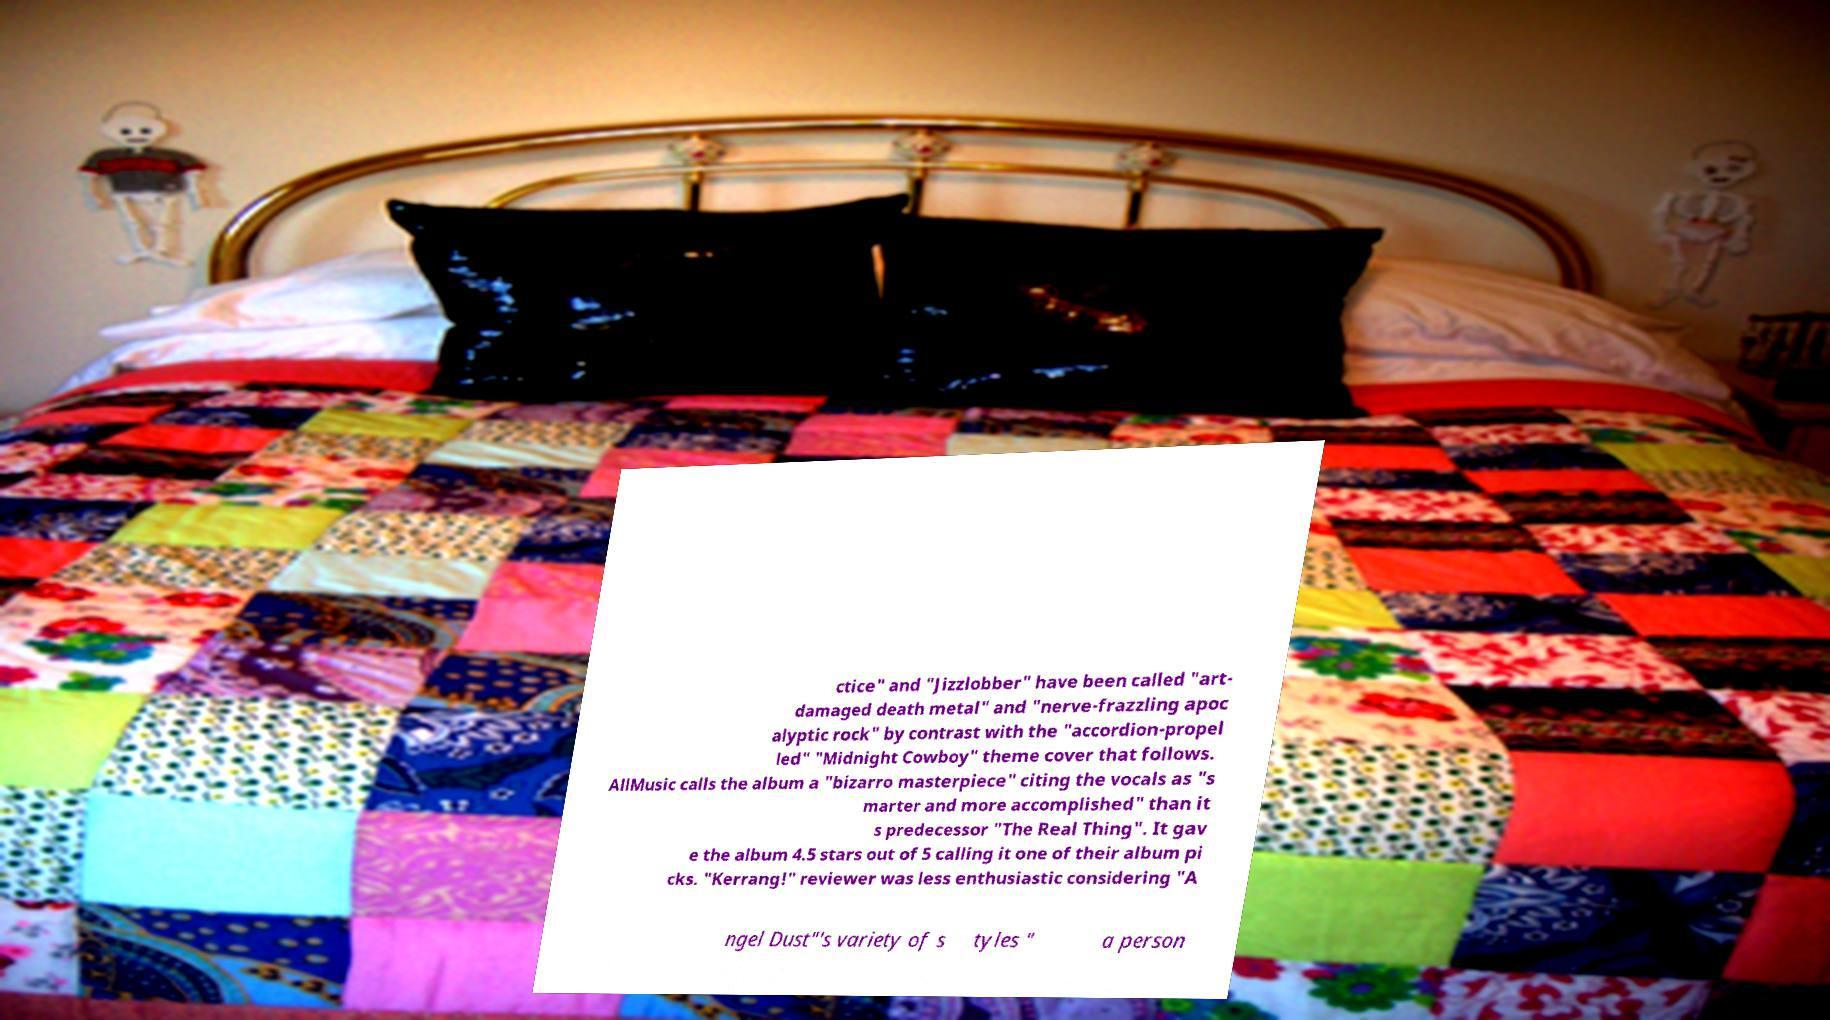Could you extract and type out the text from this image? ctice" and "Jizzlobber" have been called "art- damaged death metal" and "nerve-frazzling apoc alyptic rock" by contrast with the "accordion-propel led" "Midnight Cowboy" theme cover that follows. AllMusic calls the album a "bizarro masterpiece" citing the vocals as "s marter and more accomplished" than it s predecessor "The Real Thing". It gav e the album 4.5 stars out of 5 calling it one of their album pi cks. "Kerrang!" reviewer was less enthusiastic considering "A ngel Dust"'s variety of s tyles " a person 